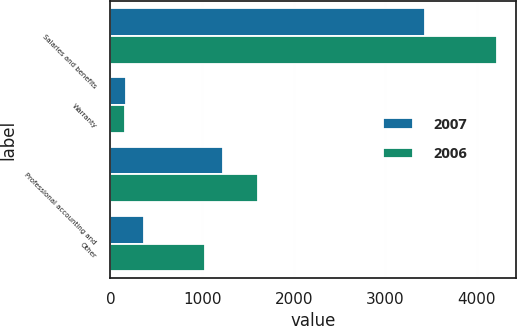Convert chart to OTSL. <chart><loc_0><loc_0><loc_500><loc_500><stacked_bar_chart><ecel><fcel>Salaries and benefits<fcel>Warranty<fcel>Professional accounting and<fcel>Other<nl><fcel>2007<fcel>3432<fcel>167<fcel>1224<fcel>362<nl><fcel>2006<fcel>4214<fcel>157<fcel>1611<fcel>1035<nl></chart> 